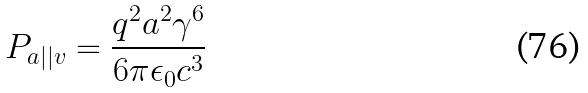<formula> <loc_0><loc_0><loc_500><loc_500>P _ { a | | v } = \frac { q ^ { 2 } a ^ { 2 } \gamma ^ { 6 } } { 6 \pi \epsilon _ { 0 } c ^ { 3 } }</formula> 